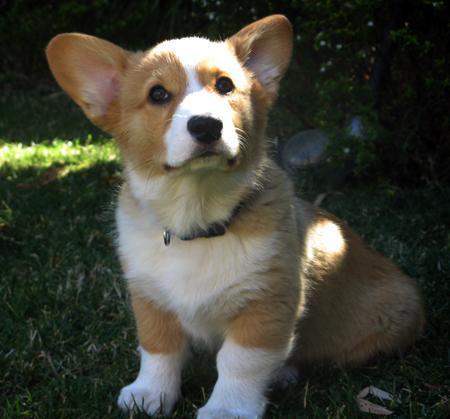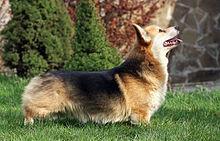The first image is the image on the left, the second image is the image on the right. Assess this claim about the two images: "A dog in one image has a partial black coat and is looking up with its mouth open.". Correct or not? Answer yes or no. Yes. 